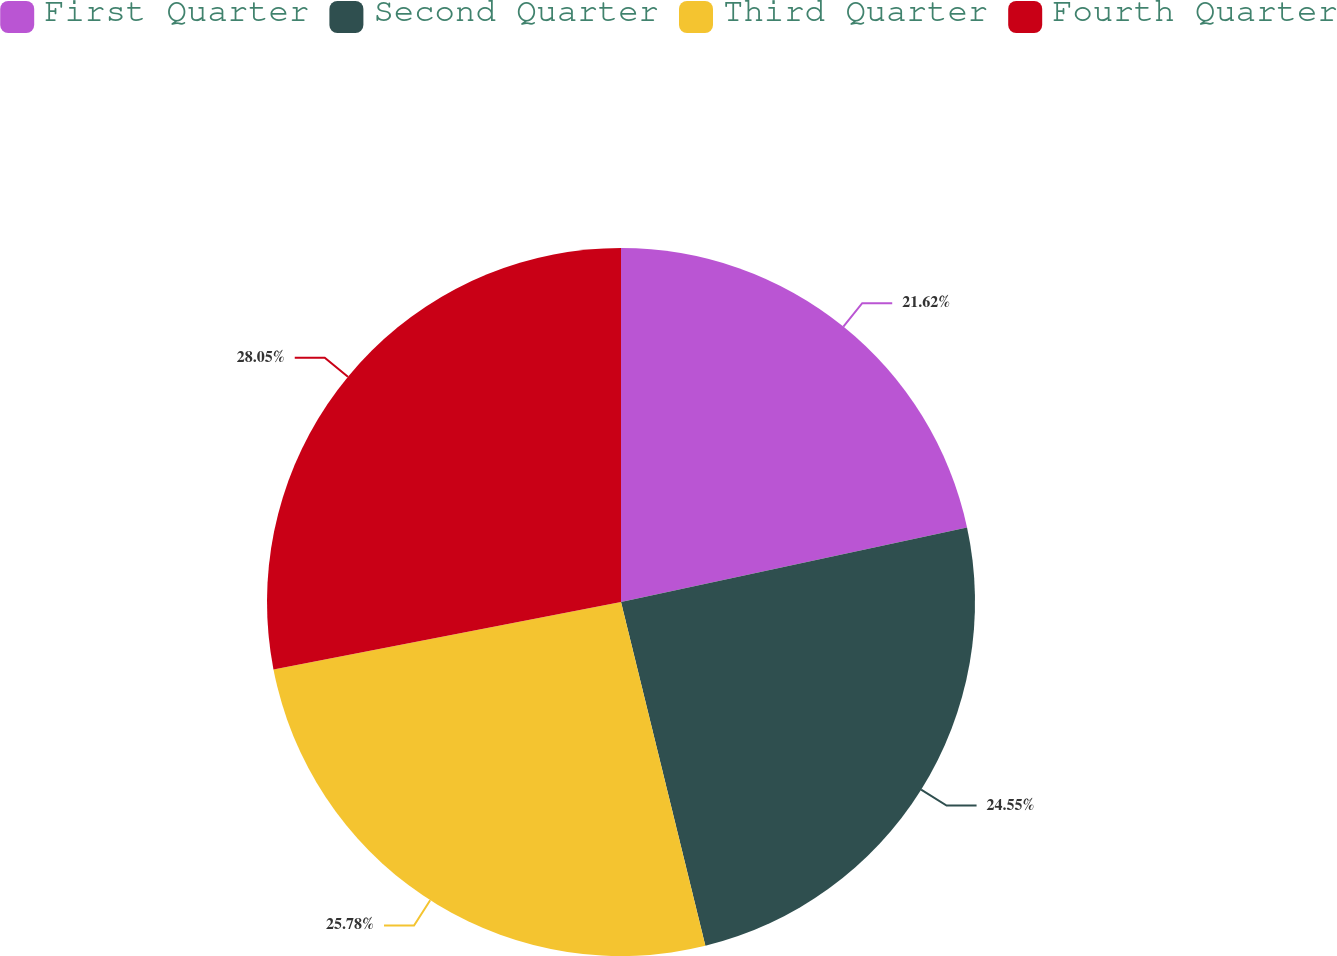Convert chart to OTSL. <chart><loc_0><loc_0><loc_500><loc_500><pie_chart><fcel>First Quarter<fcel>Second Quarter<fcel>Third Quarter<fcel>Fourth Quarter<nl><fcel>21.62%<fcel>24.55%<fcel>25.78%<fcel>28.05%<nl></chart> 